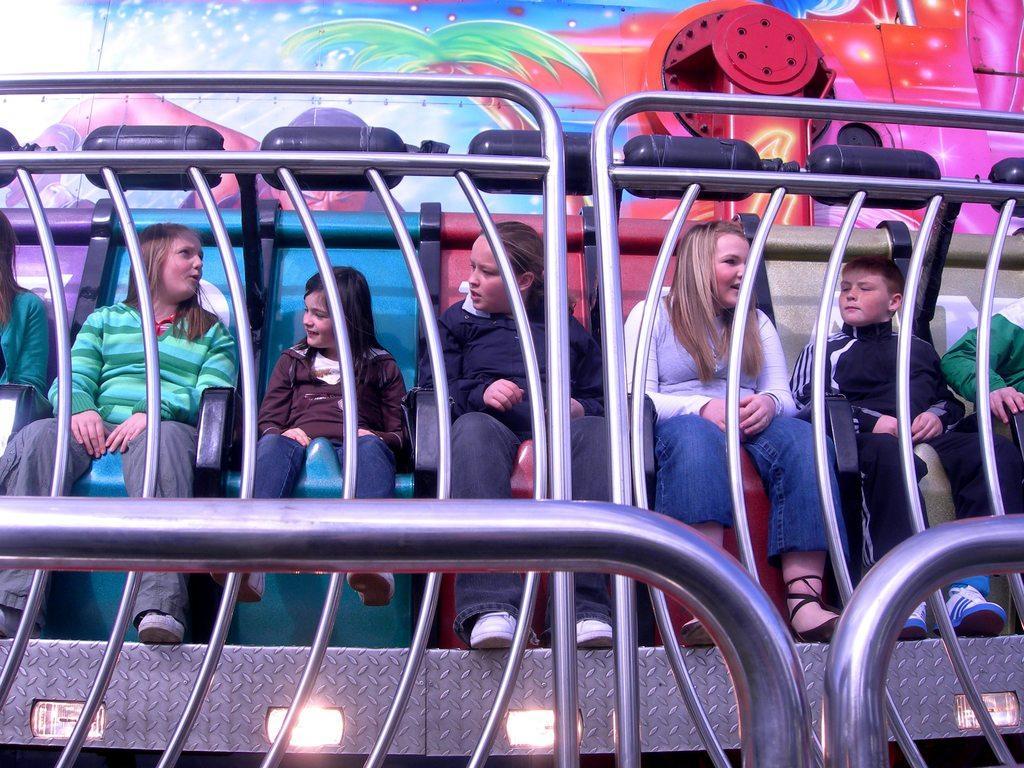Could you give a brief overview of what you see in this image? This is a roll a coaster ride. In this picture we can see a few people are sitting on the chair. There are some lights on this roll a coaster. We can see a painting in the background. 